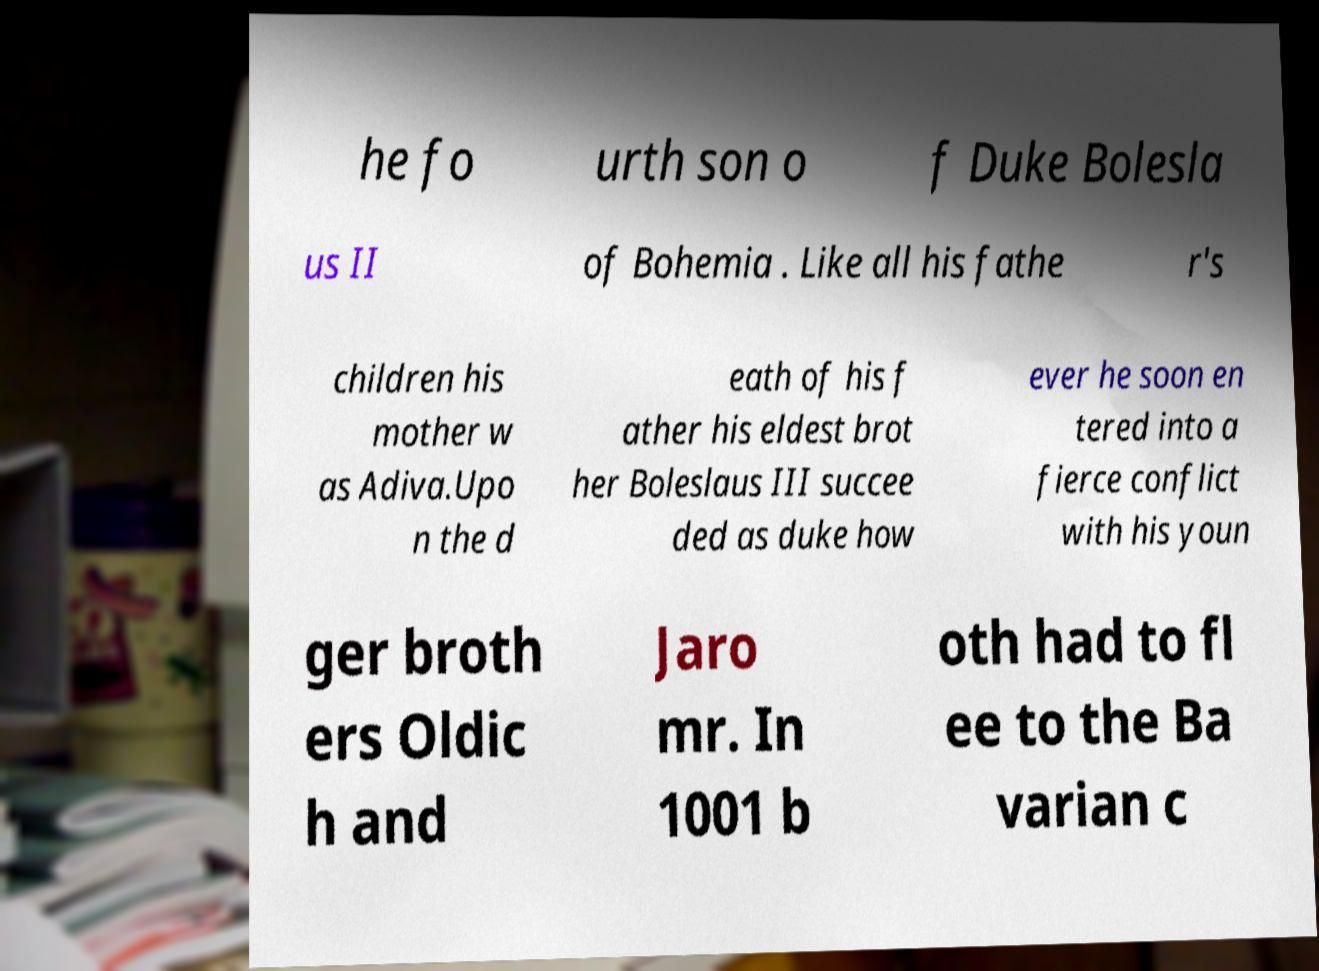I need the written content from this picture converted into text. Can you do that? he fo urth son o f Duke Bolesla us II of Bohemia . Like all his fathe r's children his mother w as Adiva.Upo n the d eath of his f ather his eldest brot her Boleslaus III succee ded as duke how ever he soon en tered into a fierce conflict with his youn ger broth ers Oldic h and Jaro mr. In 1001 b oth had to fl ee to the Ba varian c 